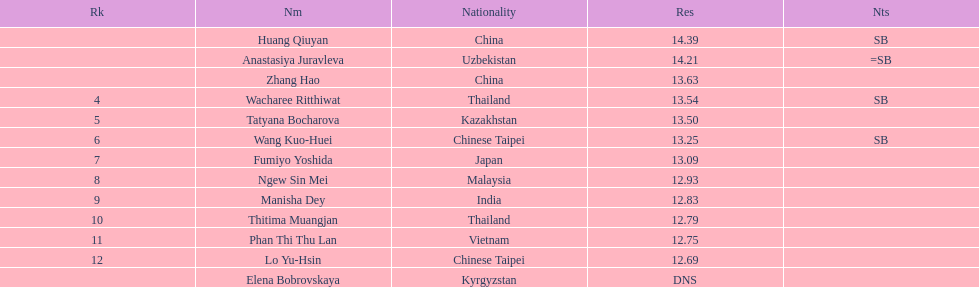How long was manisha dey's jump? 12.83. 